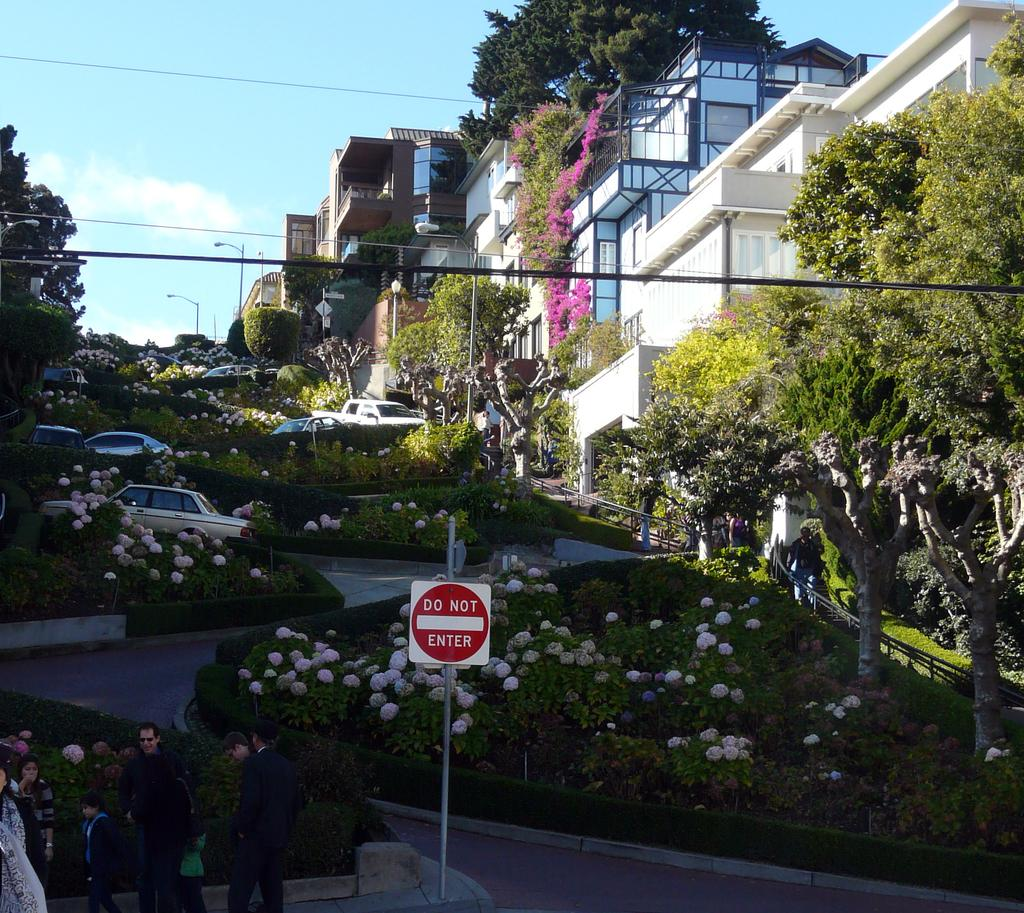What is located at the bottom of the image? There is a sign board at the bottom of the image. Where are the people in the image? The people are standing on the left side of the image. What can be seen in the background of the image? There are bushes, flowers, trees, buildings, poles, and the sky visible in the background of the image. Can you tell me what type of vessel the yak is carrying in the image? There is no yak present in the image, so it is not possible to determine what type of vessel it might be carrying. What time does the clock show in the image? There is no clock present in the image, so it is not possible to determine the time. 